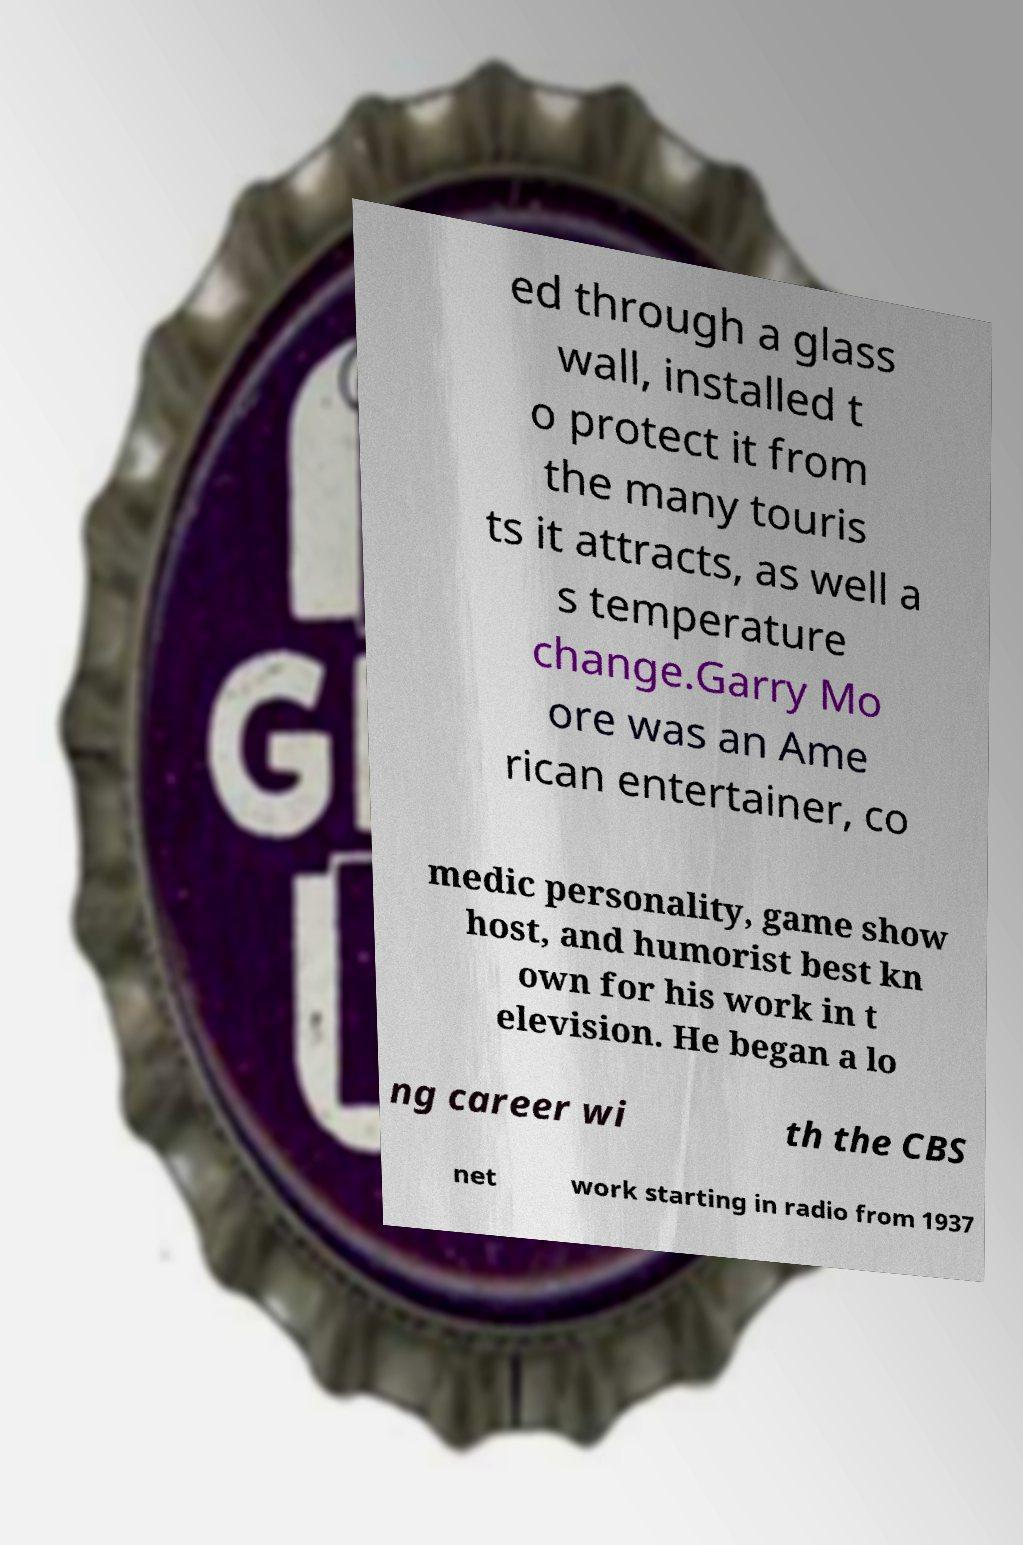Can you accurately transcribe the text from the provided image for me? ed through a glass wall, installed t o protect it from the many touris ts it attracts, as well a s temperature change.Garry Mo ore was an Ame rican entertainer, co medic personality, game show host, and humorist best kn own for his work in t elevision. He began a lo ng career wi th the CBS net work starting in radio from 1937 